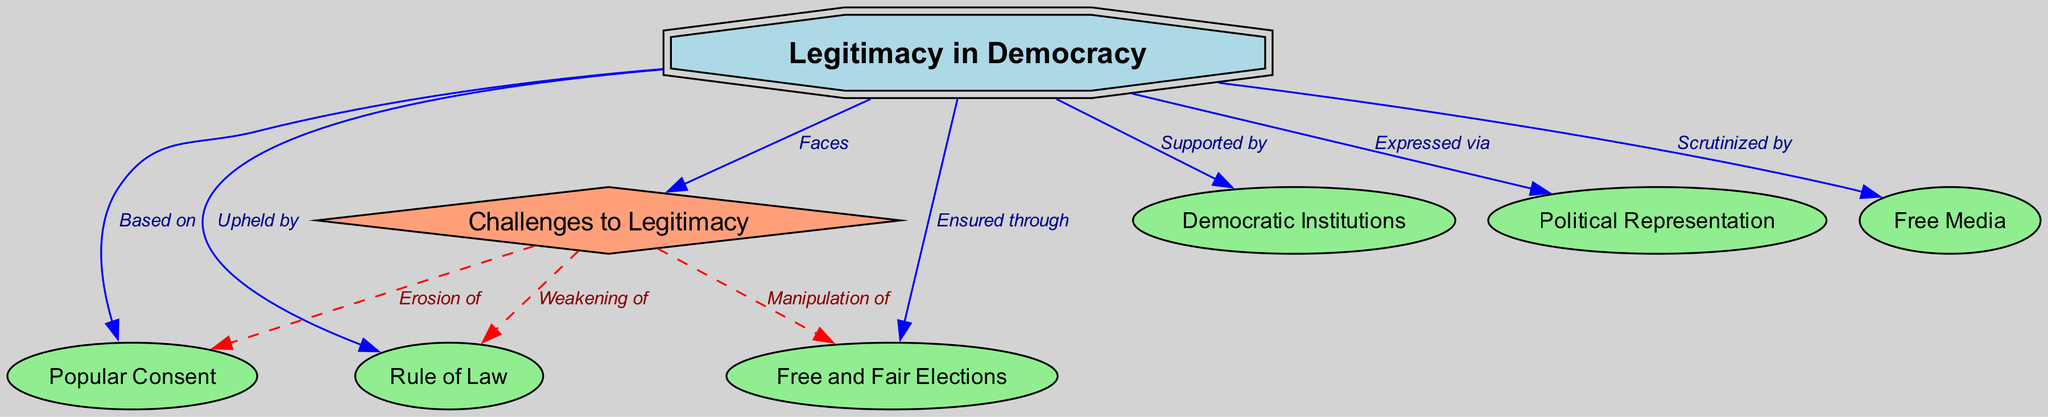What are the main components that contribute to legitimacy in a democracy? The nodes connected to "Legitimacy in Democracy" include "Popular Consent," "Free and Fair Elections," "Rule of Law," "Democratic Institutions," "Political Representation," and "Free Media."
Answer: Popular Consent, Free and Fair Elections, Rule of Law, Democratic Institutions, Political Representation, Free Media How many edges are there connecting to the "Legitimacy in Democracy" node? There are six edges connecting to "Legitimacy in Democracy." These edges represent various relationships to other concepts such as consent, elections, rule of law, etc.
Answer: 6 What does "Legitimacy in Democracy" get scrutinized by? The edge labeled "Scrutinized by" points to "Free Media." This indicates that one function of the media in a democratic setting is to examine and critique the legitimacy of the government.
Answer: Free Media What is a challenge to legitimacy related to the rule of law? The edge from "Challenges to Legitimacy" to "Rule of Law" is labeled "Weakening of," indicating that there is a direct challenge to legitimacy when the rule of law is weakened.
Answer: Weakening of How is legitimacy expressed in a democracy? The edge from "Legitimacy in Democracy" to "Political Representation" is labeled "Expressed via." This indicates that political representation is a key way through which legitimacy is manifested in democratic systems.
Answer: Political Representation What is one way that elections affect legitimacy in a democracy? The relationship is defined by the edge "Ensured through" connecting "Legitimacy in Democracy" to "Free and Fair Elections." This means that legitimacy is guaranteed or maintained through the conduct of elections that are fair and free.
Answer: Free and Fair Elections What happens when there is an erosion of popular consent? The edge from "Challenges to Legitimacy" to "Popular Consent" is labeled "Erosion of," indicating that the loss of popular support can undermine the overall legitimacy of democratic governance.
Answer: Erosion of What type of node is "Challenges to Legitimacy"? "Challenges to Legitimacy" is represented as a diamond shape in the diagram, indicating its unique status as a significant concept needing differentiation from other types of nodes.
Answer: Diamond 